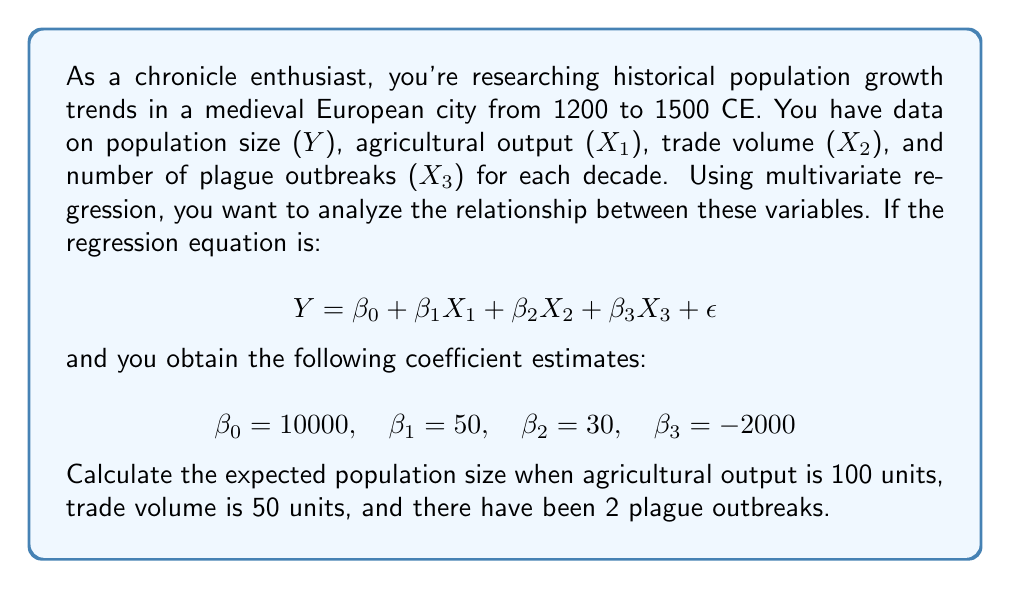Solve this math problem. To solve this problem, we'll use the multivariate regression equation and plug in the given values. Let's break it down step-by-step:

1. The regression equation is:
   $$Y = \beta_0 + \beta_1X_1 + \beta_2X_2 + \beta_3X_3 + \epsilon$$

2. We're given the following coefficient estimates:
   $\beta_0 = 10000$ (intercept)
   $\beta_1 = 50$ (coefficient for agricultural output)
   $\beta_2 = 30$ (coefficient for trade volume)
   $\beta_3 = -2000$ (coefficient for plague outbreaks)

3. We're also given the following values for our predictor variables:
   $X_1 = 100$ (agricultural output)
   $X_2 = 50$ (trade volume)
   $X_3 = 2$ (plague outbreaks)

4. We can ignore the error term $\epsilon$ when calculating the expected value.

5. Now, let's substitute these values into our equation:

   $$Y = 10000 + 50(100) + 30(50) + (-2000)(2)$$

6. Let's calculate each term:
   - $10000$ (intercept)
   - $50 * 100 = 5000$ (effect of agricultural output)
   - $30 * 50 = 1500$ (effect of trade volume)
   - $-2000 * 2 = -4000$ (effect of plague outbreaks)

7. Now, we can sum up all these terms:

   $$Y = 10000 + 5000 + 1500 - 4000 = 12500$$

Therefore, the expected population size under these conditions is 12,500.
Answer: 12,500 